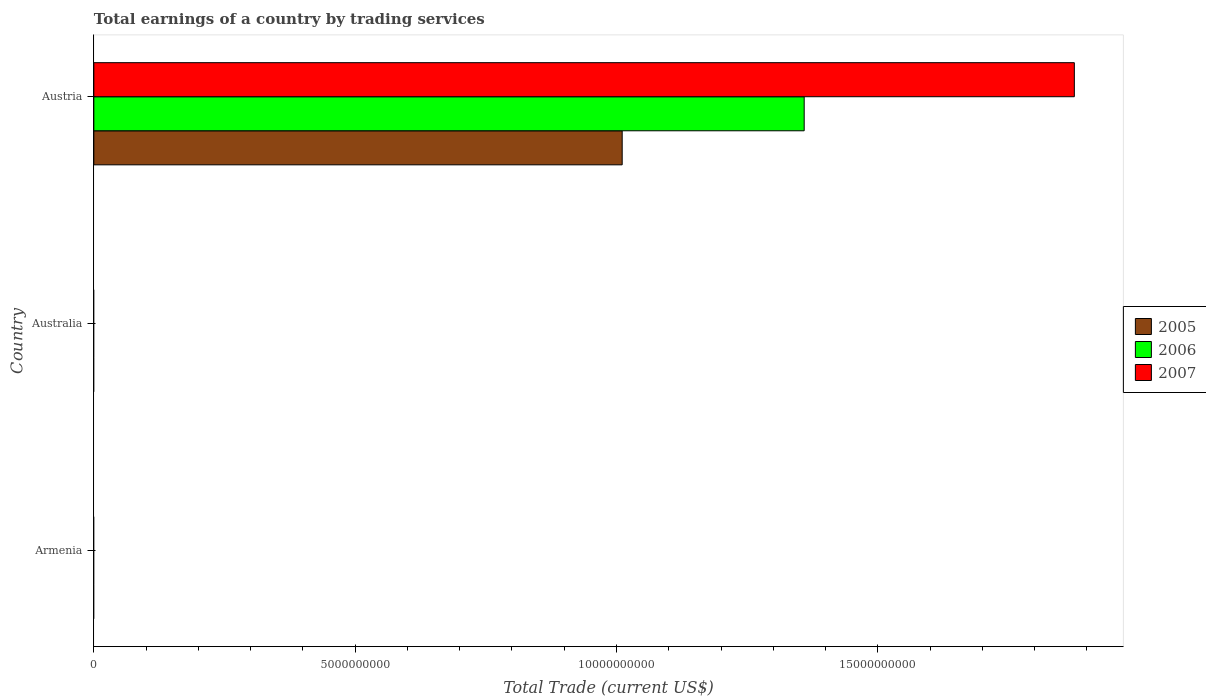Are the number of bars per tick equal to the number of legend labels?
Give a very brief answer. No. How many bars are there on the 2nd tick from the top?
Your response must be concise. 0. How many bars are there on the 2nd tick from the bottom?
Your answer should be compact. 0. In how many cases, is the number of bars for a given country not equal to the number of legend labels?
Your response must be concise. 2. Across all countries, what is the maximum total earnings in 2005?
Your response must be concise. 1.01e+1. In which country was the total earnings in 2005 maximum?
Provide a short and direct response. Austria. What is the total total earnings in 2007 in the graph?
Provide a short and direct response. 1.88e+1. What is the average total earnings in 2007 per country?
Make the answer very short. 6.25e+09. What is the difference between the total earnings in 2005 and total earnings in 2007 in Austria?
Provide a short and direct response. -8.65e+09. What is the difference between the highest and the lowest total earnings in 2006?
Provide a succinct answer. 1.36e+1. In how many countries, is the total earnings in 2005 greater than the average total earnings in 2005 taken over all countries?
Keep it short and to the point. 1. Is it the case that in every country, the sum of the total earnings in 2006 and total earnings in 2007 is greater than the total earnings in 2005?
Provide a succinct answer. No. How many bars are there?
Ensure brevity in your answer.  3. Where does the legend appear in the graph?
Keep it short and to the point. Center right. How many legend labels are there?
Ensure brevity in your answer.  3. How are the legend labels stacked?
Provide a succinct answer. Vertical. What is the title of the graph?
Your response must be concise. Total earnings of a country by trading services. Does "2013" appear as one of the legend labels in the graph?
Your response must be concise. No. What is the label or title of the X-axis?
Provide a succinct answer. Total Trade (current US$). What is the label or title of the Y-axis?
Provide a succinct answer. Country. What is the Total Trade (current US$) of 2006 in Armenia?
Keep it short and to the point. 0. What is the Total Trade (current US$) of 2007 in Armenia?
Your answer should be very brief. 0. What is the Total Trade (current US$) of 2006 in Australia?
Provide a short and direct response. 0. What is the Total Trade (current US$) of 2005 in Austria?
Make the answer very short. 1.01e+1. What is the Total Trade (current US$) of 2006 in Austria?
Offer a terse response. 1.36e+1. What is the Total Trade (current US$) in 2007 in Austria?
Your answer should be compact. 1.88e+1. Across all countries, what is the maximum Total Trade (current US$) of 2005?
Your answer should be compact. 1.01e+1. Across all countries, what is the maximum Total Trade (current US$) in 2006?
Ensure brevity in your answer.  1.36e+1. Across all countries, what is the maximum Total Trade (current US$) in 2007?
Give a very brief answer. 1.88e+1. Across all countries, what is the minimum Total Trade (current US$) of 2005?
Keep it short and to the point. 0. Across all countries, what is the minimum Total Trade (current US$) in 2007?
Offer a very short reply. 0. What is the total Total Trade (current US$) in 2005 in the graph?
Provide a short and direct response. 1.01e+1. What is the total Total Trade (current US$) in 2006 in the graph?
Make the answer very short. 1.36e+1. What is the total Total Trade (current US$) in 2007 in the graph?
Provide a short and direct response. 1.88e+1. What is the average Total Trade (current US$) in 2005 per country?
Your answer should be very brief. 3.37e+09. What is the average Total Trade (current US$) of 2006 per country?
Offer a terse response. 4.53e+09. What is the average Total Trade (current US$) of 2007 per country?
Keep it short and to the point. 6.25e+09. What is the difference between the Total Trade (current US$) in 2005 and Total Trade (current US$) in 2006 in Austria?
Offer a terse response. -3.48e+09. What is the difference between the Total Trade (current US$) in 2005 and Total Trade (current US$) in 2007 in Austria?
Offer a terse response. -8.65e+09. What is the difference between the Total Trade (current US$) of 2006 and Total Trade (current US$) of 2007 in Austria?
Provide a short and direct response. -5.17e+09. What is the difference between the highest and the lowest Total Trade (current US$) of 2005?
Provide a succinct answer. 1.01e+1. What is the difference between the highest and the lowest Total Trade (current US$) of 2006?
Offer a very short reply. 1.36e+1. What is the difference between the highest and the lowest Total Trade (current US$) in 2007?
Provide a succinct answer. 1.88e+1. 